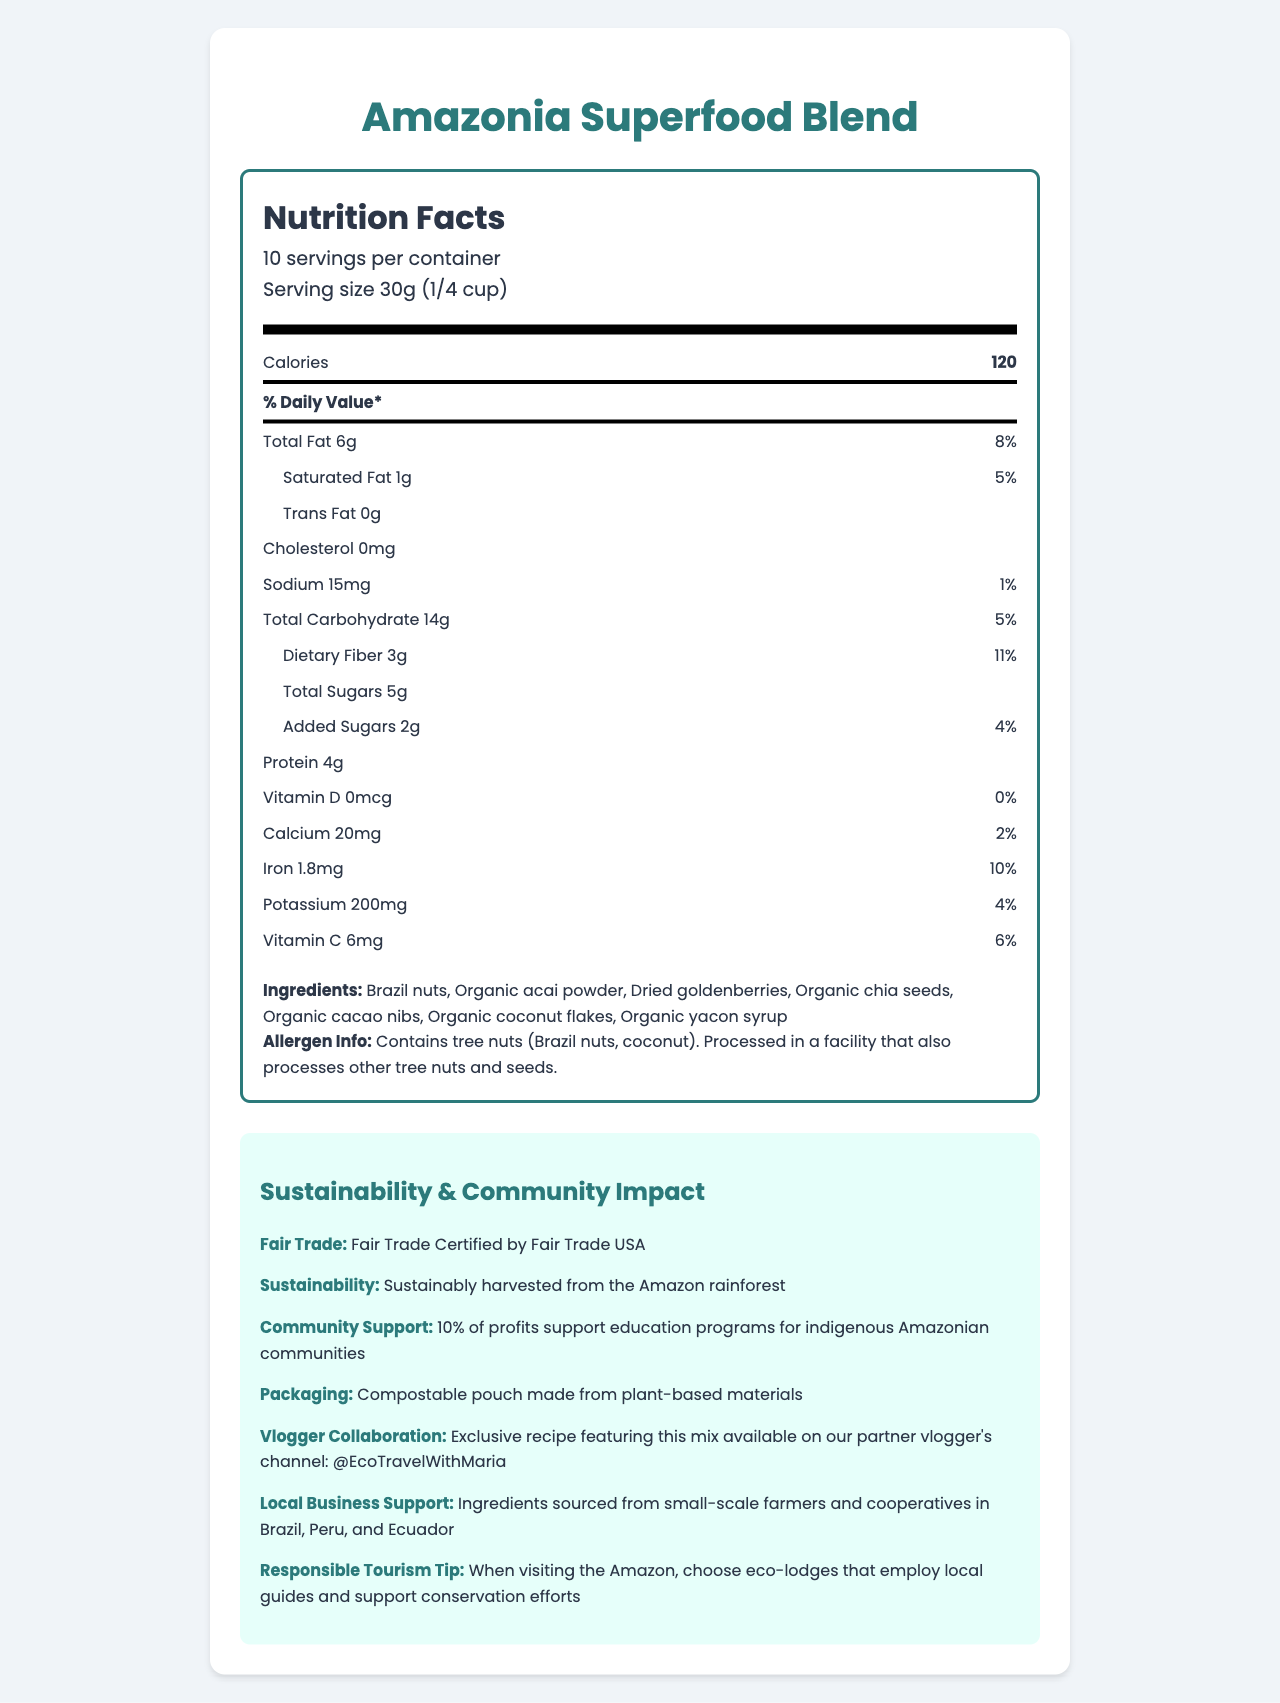what is the serving size? The serving size information is clearly stated as "30g (1/4 cup)" on the document.
Answer: 30g (1/4 cup) how many calories are in one serving? The document lists the calories per serving as 120.
Answer: 120 which ingredient provides dietary fiber? Typically, ingredients like chia seeds and berries are good sources of dietary fiber, and "organic chia seeds" and "dried goldenberries" are listed in the ingredients.
Answer: Organic chia seeds and Dried goldenberries what is the amount of calcium per serving? The amount of calcium per serving is listed as 20mg.
Answer: 20mg how does the product support indigenous communities? The document states that 10% of profits support education programs for indigenous Amazonian communities.
Answer: 10% of profits support education programs for indigenous Amazonian communities what is the fair trade certification of the product? A. Fair Trade Certified by Fair Trade International B. Fair Trade Certified by Fair Trade USA C. Fair Trade Certified by WFTO The product is Fair Trade Certified by Fair Trade USA as mentioned in the document.
Answer: B. Fair Trade Certified by Fair Trade USA which of the following is a responsible tourism tip mentioned in the document? I. Always leave no trace II. Support local businesses III. Choose eco-lodges employing local guides As per the document, the responsible tourism tip is to "choose eco-lodges that employ local guides and support conservation efforts."
Answer: III. Choose eco-lodges employing local guides does the product contain any added sugars? The document lists "Added Sugars 2g" indicating that it contains added sugars.
Answer: Yes describe the main idea of the document The document contains a nutrition facts label, ingredients list, allergen information, and additional eco-friendly and community support details about the product.
Answer: The document provides detailed nutritional information and highlights the sustainability, fair trade certification, and community impact of the "Amazonia Superfood Blend", a fair trade, sustainably harvested superfood snack mix designed to support indigenous communities. what is the percentage daily value of protein per serving? The document does not provide the percentage daily value for protein, so it cannot be determined from the information given.
Answer: Cannot be determined 